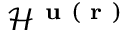Convert formula to latex. <formula><loc_0><loc_0><loc_500><loc_500>{ \mathcal { H } } ^ { u ( r ) }</formula> 